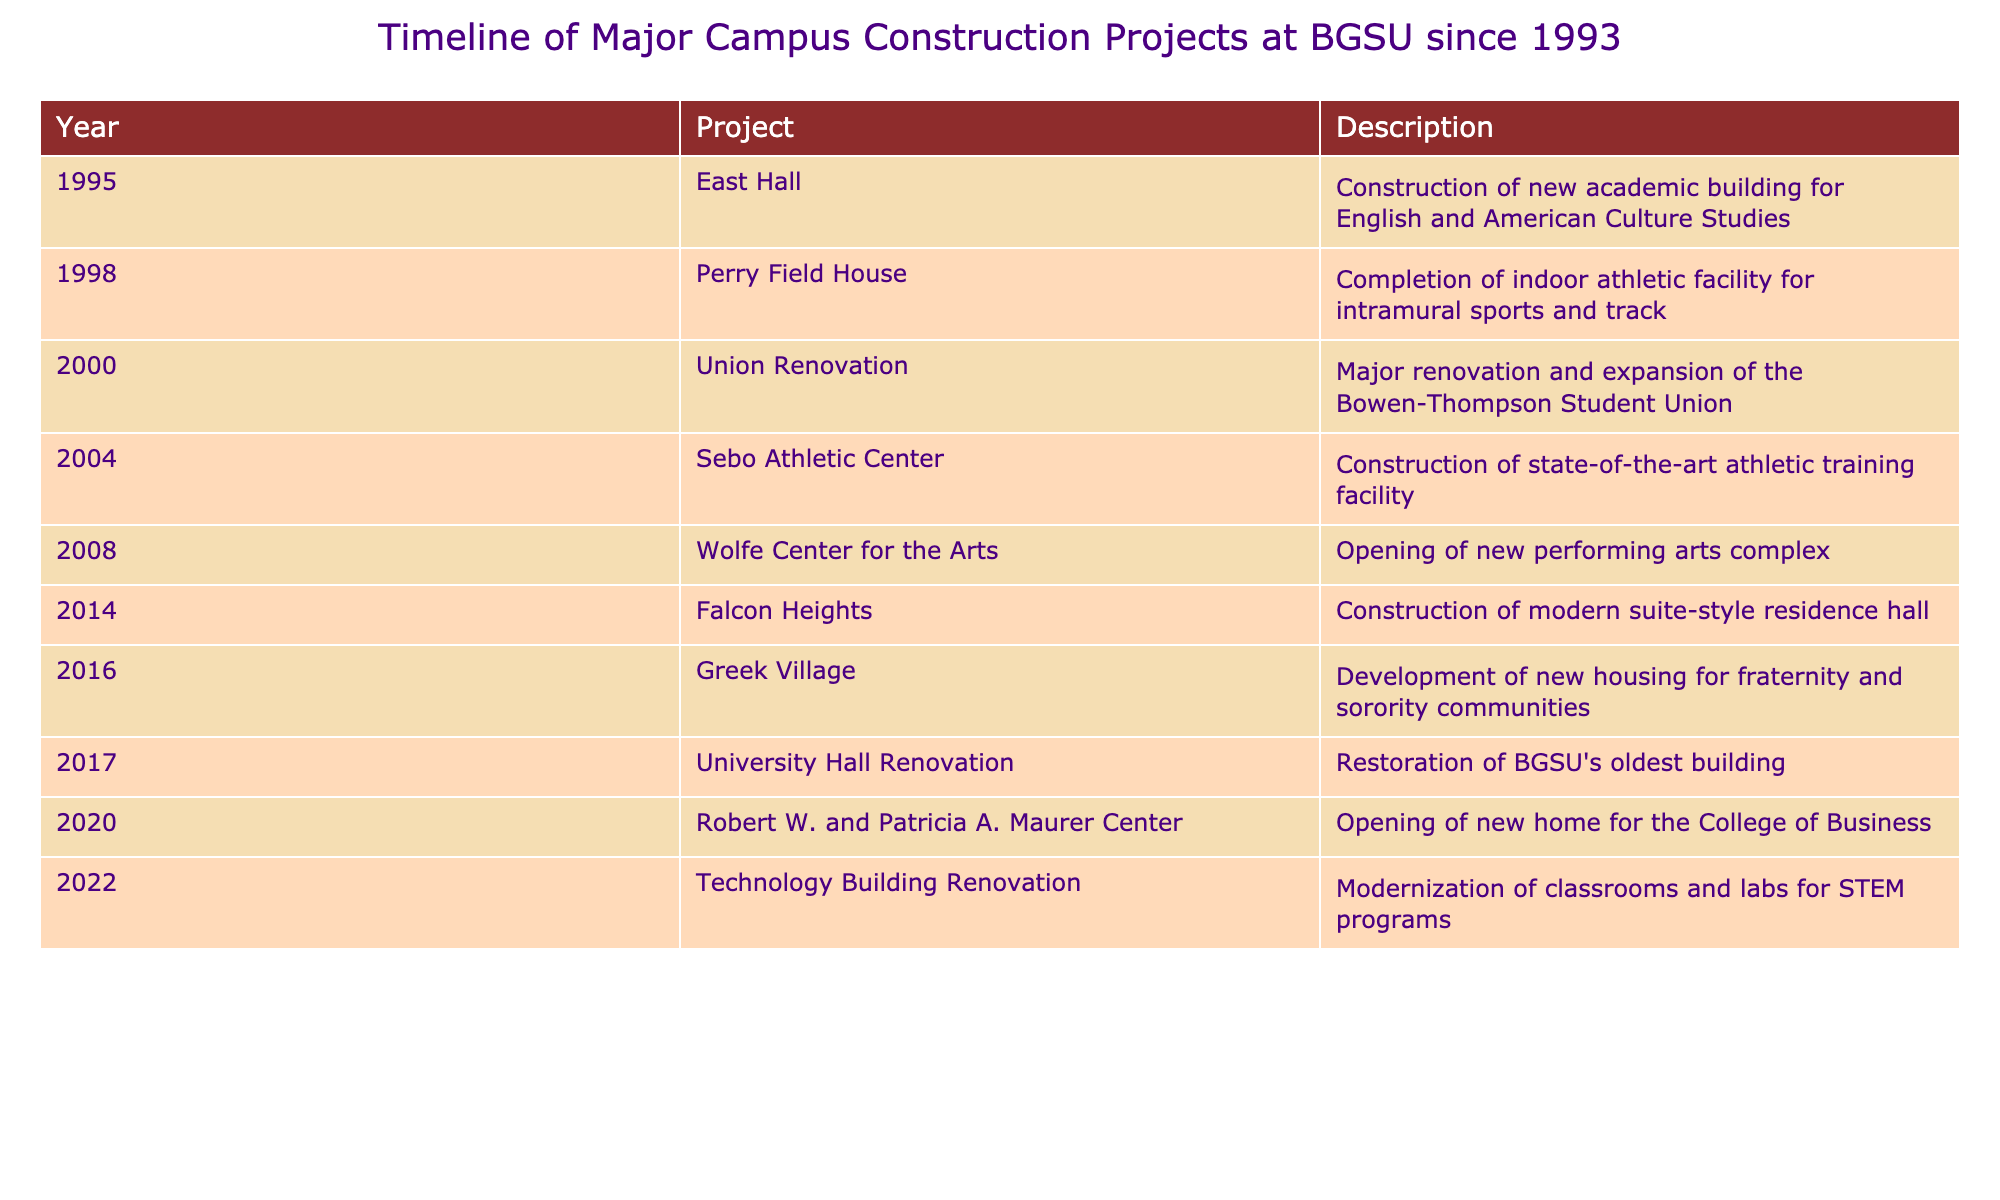What was the first major construction project completed after 1993? According to the timeline, the first major construction project mentioned after 1993 is East Hall, which was completed in 1995.
Answer: East Hall How many years apart were the construction of the Wolfe Center for the Arts and the Robert W. and Patricia A. Maurer Center? The Wolfe Center for the Arts was completed in 2008, and the Robert W. and Patricia A. Maurer Center was completed in 2020. The difference in years is 2020 - 2008 = 12 years.
Answer: 12 years Did BGSU complete any athletic facilities before 2010? Yes, both Perry Field House (completed in 1998) and the Sebo Athletic Center (completed in 2004) were constructed before 2010.
Answer: Yes What percentage of the projects listed were completed in the 2010s? There are 4 projects completed in the 2010s (Falcon Heights in 2014, Greek Village in 2016, University Hall Renovation in 2017, and the Robert W. and Patricia A. Maurer Center in 2020) out of 10 total projects. The percentage is (4/10) * 100 = 40%.
Answer: 40% Which project involved the oldest building at BGSU? The project related to the oldest building at BGSU is the University Hall Renovation, which took place in 2017.
Answer: University Hall Renovation How many total major construction projects were completed from 1993 to 2022? The table lists a total of 10 major construction projects completed from 1993 to 2022.
Answer: 10 projects Was there a project completed in 2022? Yes, there was a project called Technology Building Renovation completed in 2022.
Answer: Yes Which project was completed most recently, and what was its purpose? The most recent project listed is the Technology Building Renovation completed in 2022, modernizing classrooms and labs for STEM programs.
Answer: Technology Building Renovation, modernizing classrooms and labs for STEM programs 